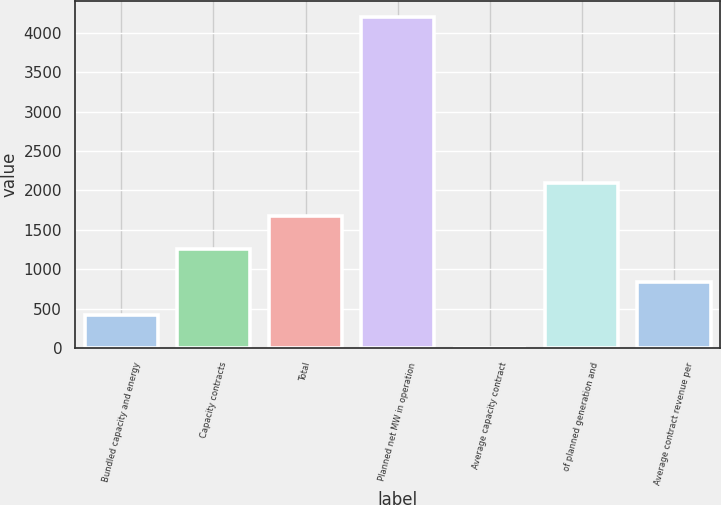<chart> <loc_0><loc_0><loc_500><loc_500><bar_chart><fcel>Bundled capacity and energy<fcel>Capacity contracts<fcel>Total<fcel>Planned net MW in operation<fcel>Average capacity contract<fcel>of planned generation and<fcel>Average contract revenue per<nl><fcel>420.99<fcel>1260.77<fcel>1680.66<fcel>4200<fcel>1.1<fcel>2100.55<fcel>840.88<nl></chart> 